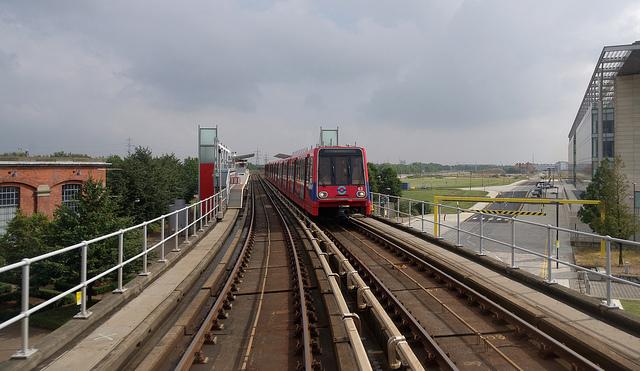What color is the front of the train?
Write a very short answer. Red. How many tracks?
Write a very short answer. 2. Are there clouds in this picture?
Quick response, please. Yes. What color is the train?
Quick response, please. Red. 